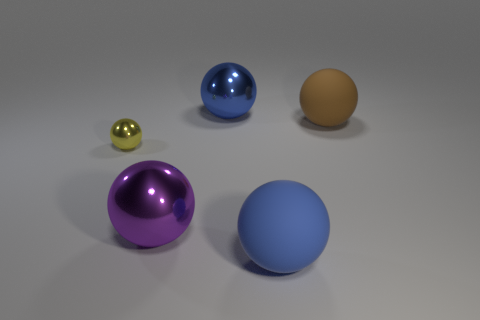Subtract 1 spheres. How many spheres are left? 4 Subtract all blue spheres. How many spheres are left? 3 Subtract all small balls. How many balls are left? 4 Subtract all cyan spheres. Subtract all blue cubes. How many spheres are left? 5 Add 2 big blue rubber spheres. How many objects exist? 7 Add 2 tiny yellow objects. How many tiny yellow objects exist? 3 Subtract 1 purple spheres. How many objects are left? 4 Subtract all yellow things. Subtract all large balls. How many objects are left? 0 Add 2 large purple metallic spheres. How many large purple metallic spheres are left? 3 